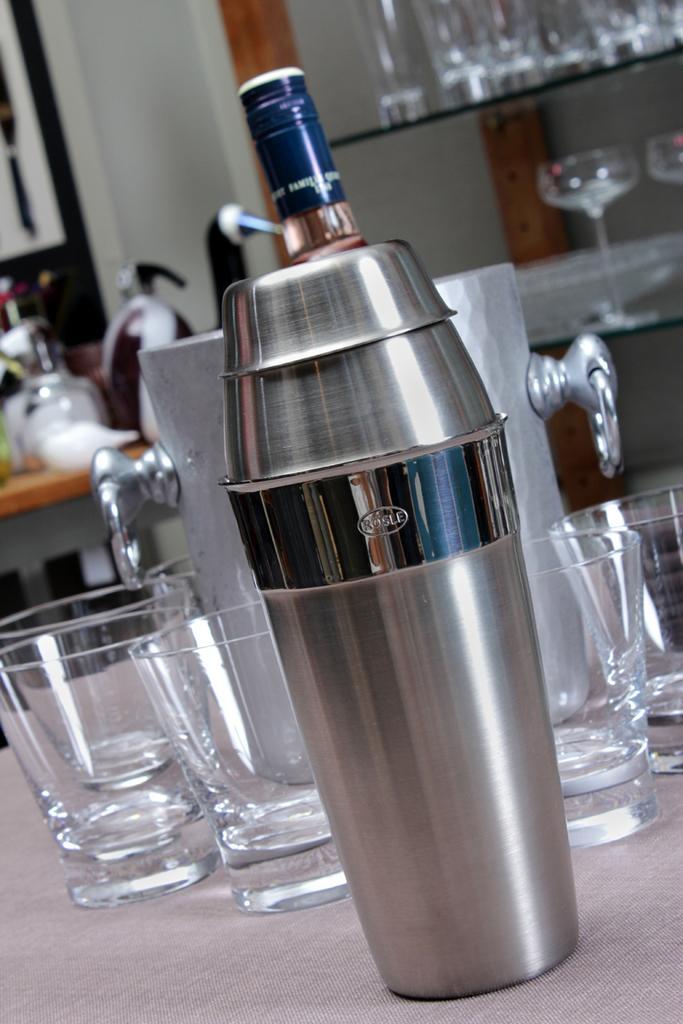Describe this image in one or two sentences. In this image I see few glasses and a bottle over here. 